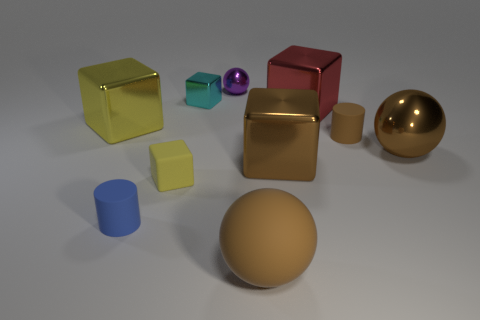Are there more small blue matte cylinders than green metallic spheres?
Provide a succinct answer. Yes. What number of other things are there of the same color as the tiny metallic cube?
Offer a terse response. 0. How many shiny things are both on the right side of the large yellow metallic block and left of the blue rubber cylinder?
Your answer should be very brief. 0. Is the number of yellow rubber blocks that are on the right side of the brown metallic sphere greater than the number of brown cylinders that are left of the big red metal object?
Your answer should be very brief. No. There is a tiny blue cylinder that is in front of the large brown block; what material is it?
Make the answer very short. Rubber. Does the tiny cyan shiny thing have the same shape as the large shiny thing to the right of the large red thing?
Provide a short and direct response. No. There is a large ball in front of the cylinder to the left of the large matte object; what number of brown rubber objects are on the right side of it?
Your response must be concise. 1. What color is the other small thing that is the same shape as the tiny blue thing?
Make the answer very short. Brown. Is there any other thing that has the same shape as the yellow shiny thing?
Your answer should be very brief. Yes. What number of blocks are either tiny brown things or yellow metal objects?
Your response must be concise. 1. 